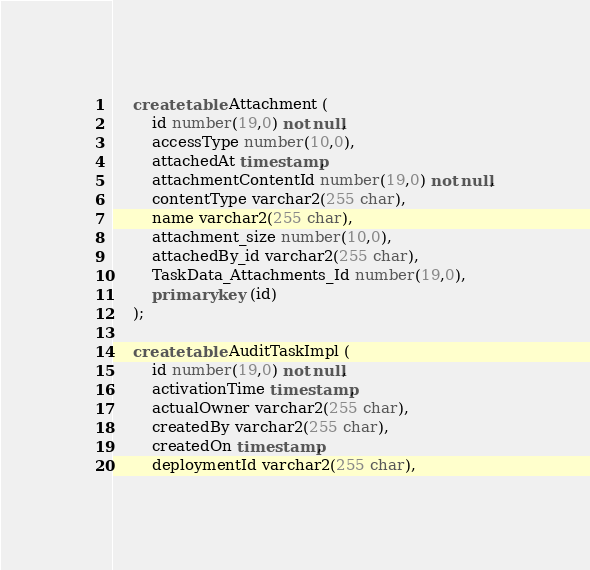<code> <loc_0><loc_0><loc_500><loc_500><_SQL_>    create table Attachment (
        id number(19,0) not null,
        accessType number(10,0),
        attachedAt timestamp,
        attachmentContentId number(19,0) not null,
        contentType varchar2(255 char),
        name varchar2(255 char),
        attachment_size number(10,0),
        attachedBy_id varchar2(255 char),
        TaskData_Attachments_Id number(19,0),
        primary key (id)
    );

    create table AuditTaskImpl (
        id number(19,0) not null,
        activationTime timestamp,
        actualOwner varchar2(255 char),
        createdBy varchar2(255 char),
        createdOn timestamp,
        deploymentId varchar2(255 char),</code> 